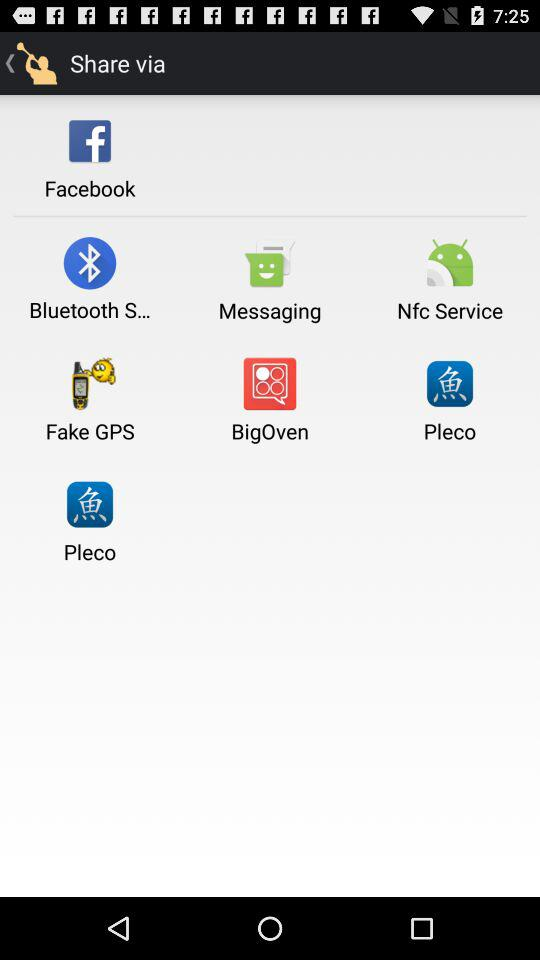What are the different options available for sharing? The different options available for sharing are "Facebook", "Bluetooth S...", "Messaging", "Nfc Service", "Fake GPS", "BigOven" and "Pleco". 